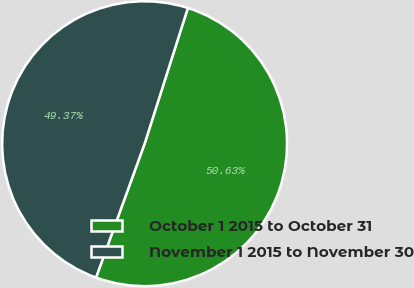Convert chart to OTSL. <chart><loc_0><loc_0><loc_500><loc_500><pie_chart><fcel>October 1 2015 to October 31<fcel>November 1 2015 to November 30<nl><fcel>50.63%<fcel>49.37%<nl></chart> 